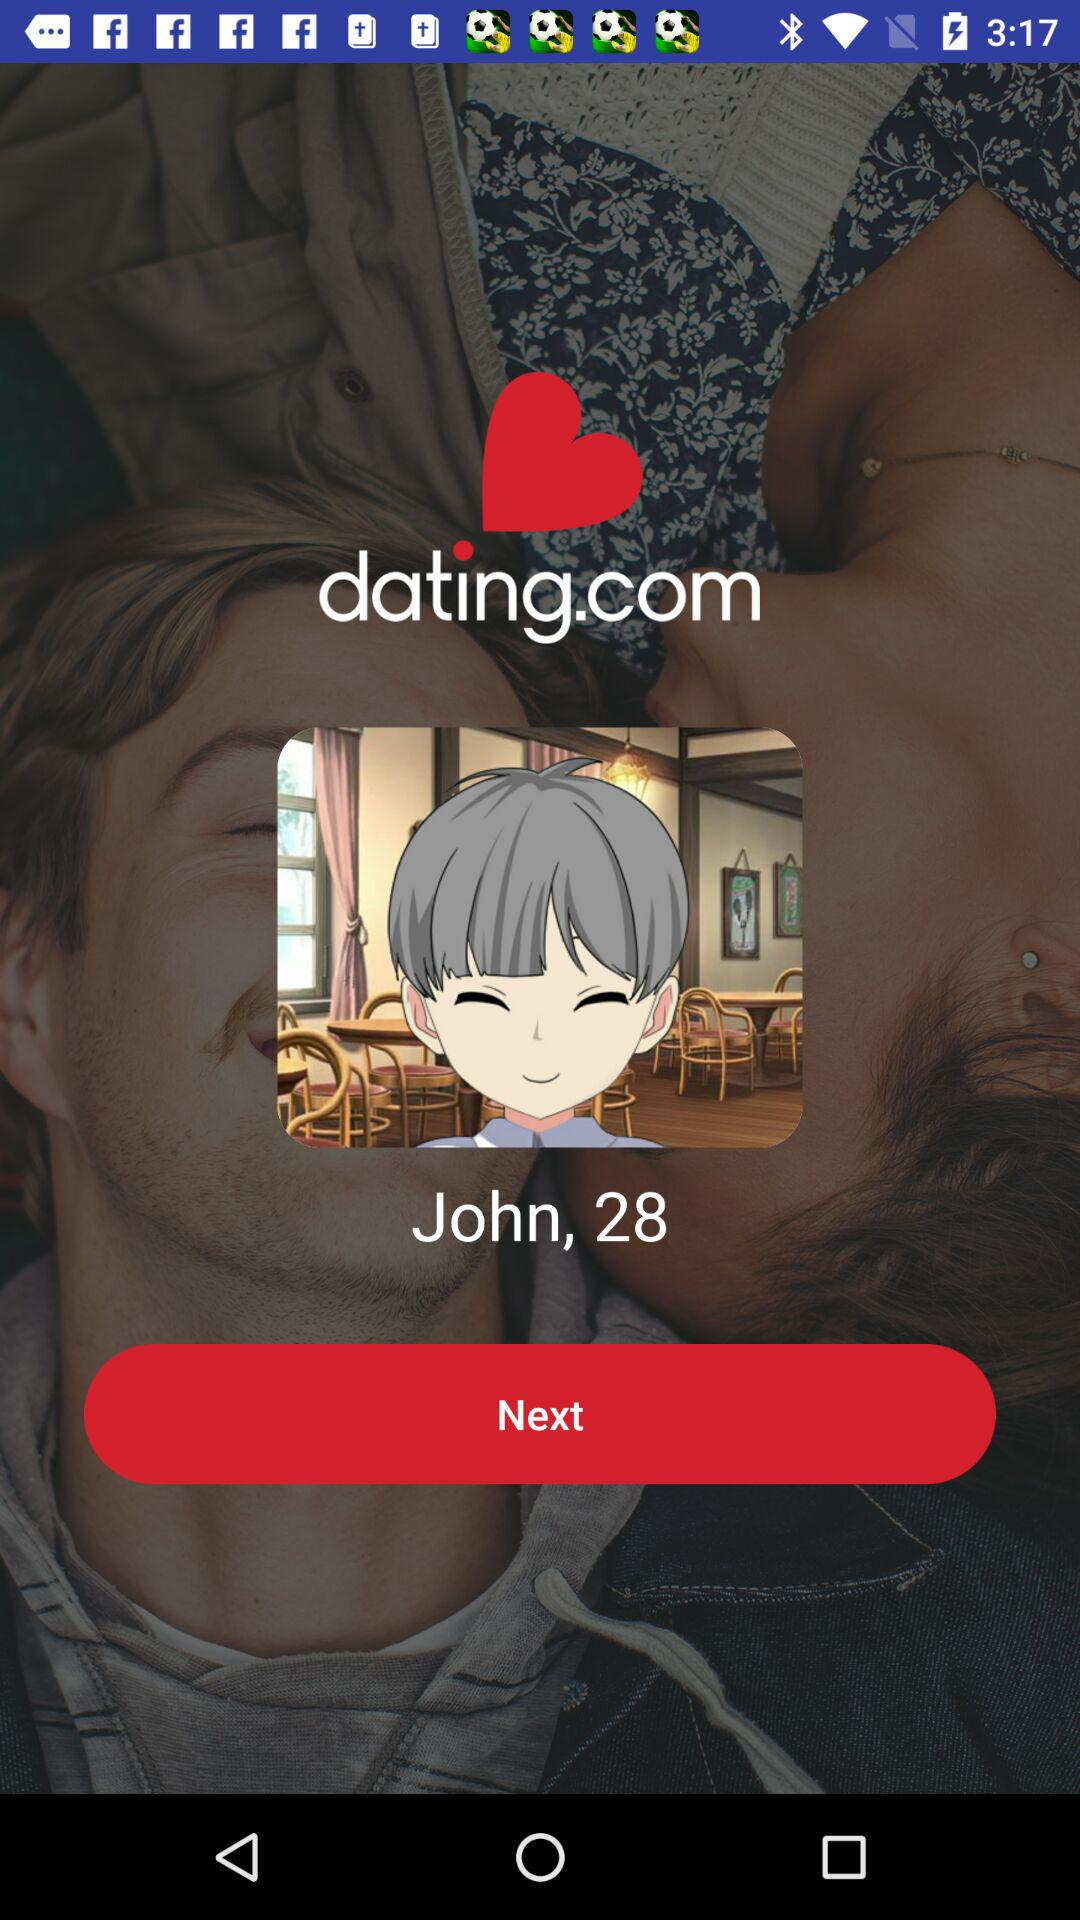What is the age of John? John is 28 years old. 